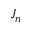<formula> <loc_0><loc_0><loc_500><loc_500>J _ { n }</formula> 